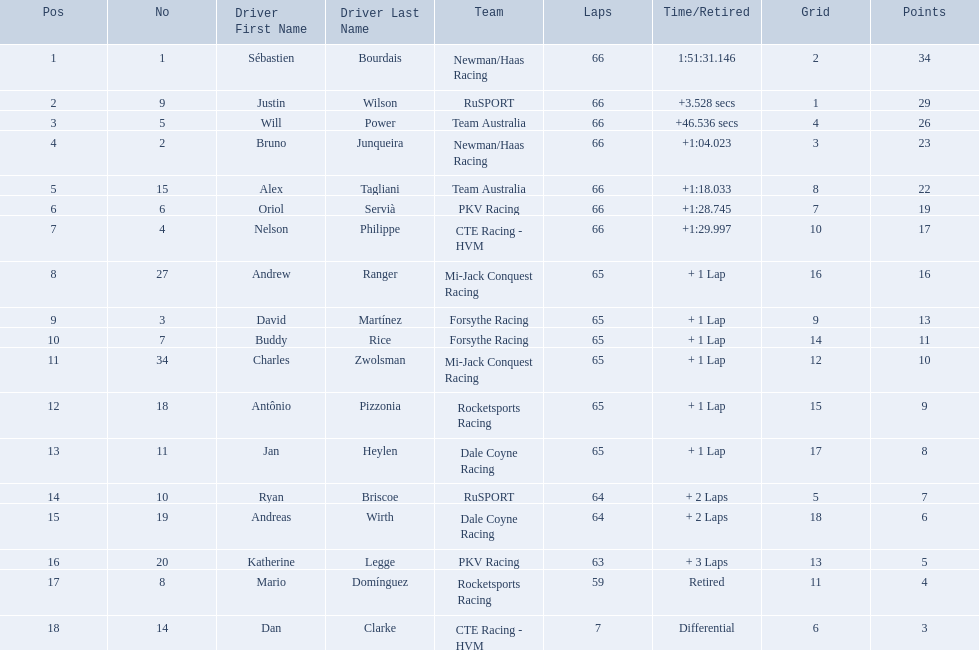What are the names of the drivers who were in position 14 through position 18? Ryan Briscoe, Andreas Wirth, Katherine Legge, Mario Domínguez, Dan Clarke. Of these , which ones didn't finish due to retired or differential? Mario Domínguez, Dan Clarke. Which one of the previous drivers retired? Mario Domínguez. Which of the drivers in question 2 had a differential? Dan Clarke. 